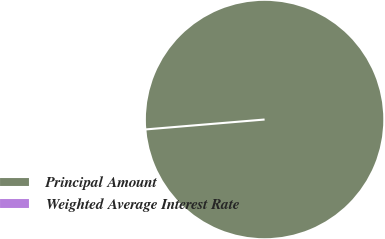Convert chart to OTSL. <chart><loc_0><loc_0><loc_500><loc_500><pie_chart><fcel>Principal Amount<fcel>Weighted Average Interest Rate<nl><fcel>100.0%<fcel>0.0%<nl></chart> 